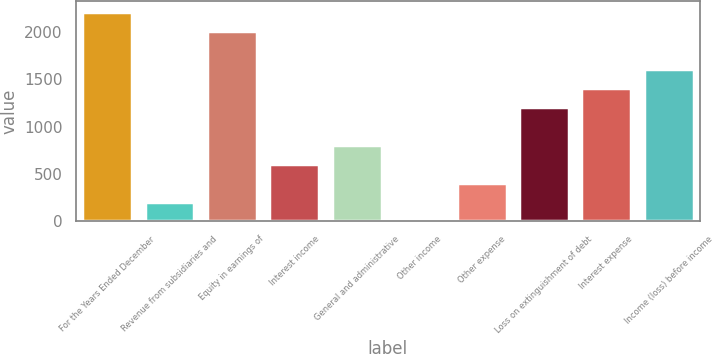Convert chart to OTSL. <chart><loc_0><loc_0><loc_500><loc_500><bar_chart><fcel>For the Years Ended December<fcel>Revenue from subsidiaries and<fcel>Equity in earnings of<fcel>Interest income<fcel>General and administrative<fcel>Other income<fcel>Other expense<fcel>Loss on extinguishment of debt<fcel>Interest expense<fcel>Income (loss) before income<nl><fcel>2214.6<fcel>208.6<fcel>2014<fcel>609.8<fcel>810.4<fcel>8<fcel>409.2<fcel>1211.6<fcel>1412.2<fcel>1612.8<nl></chart> 